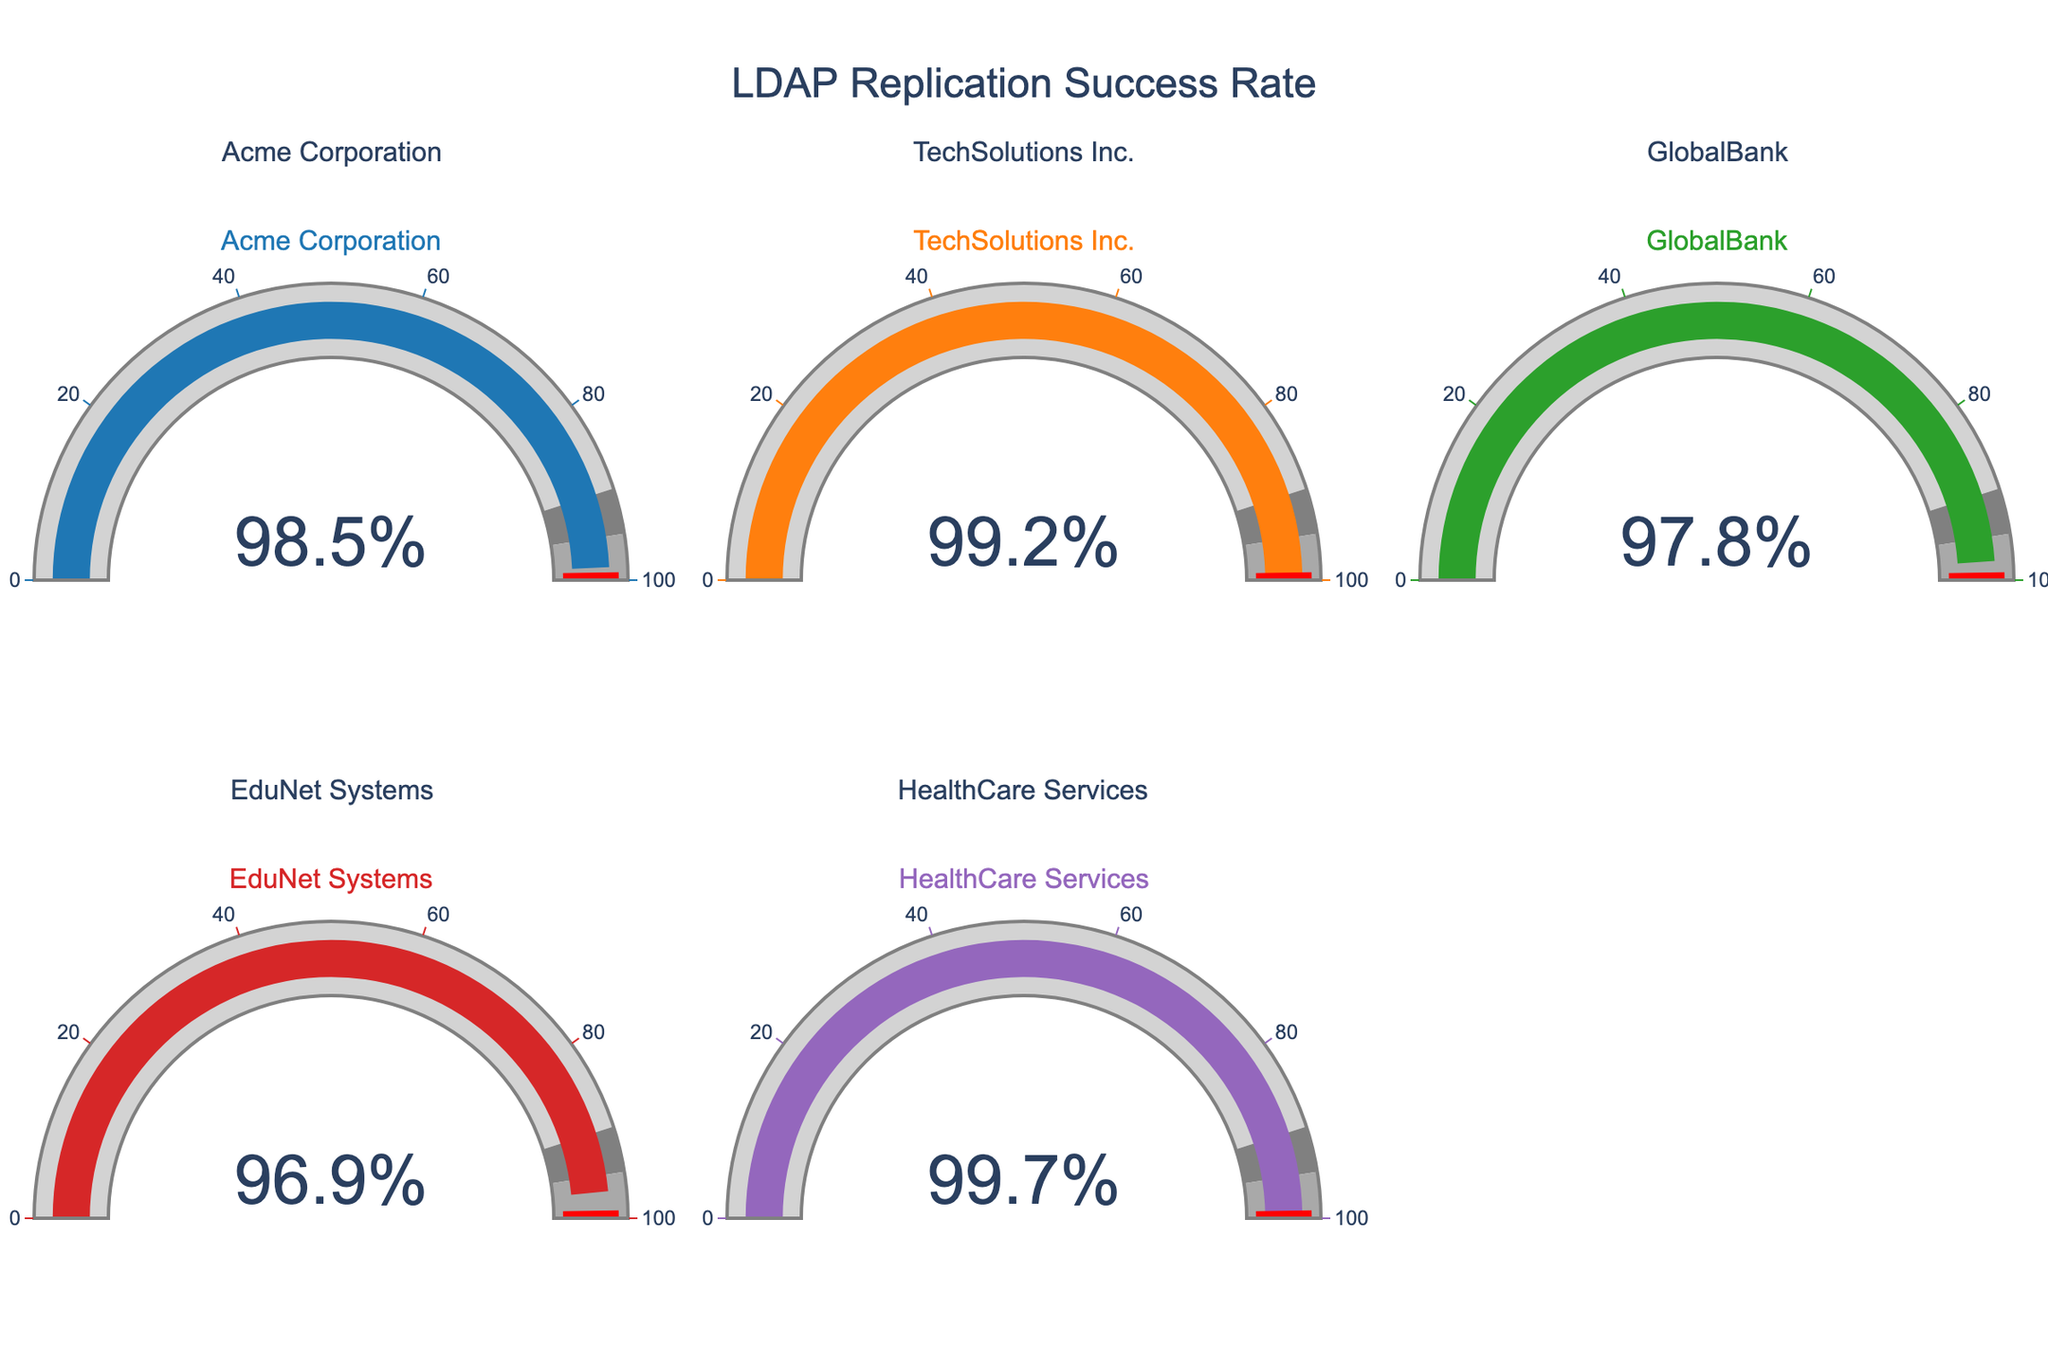What is the title of the figure? The title is usually positioned at the top of the figure and provides a brief description of what the figure is about. In this case, the title is "LDAP Replication Success Rate".
Answer: LDAP Replication Success Rate Which organization has the highest replication success rate? The Gauge Chart shows replication success rates for different organizations. By comparing the values displayed, the highest replication success rate is seen for HealthCare Services at 99.7%.
Answer: HealthCare Services What is the replication success rate for EduNet Systems? Each gauge in the figure explicitly shows the success rate for respective organizations. The success rate for EduNet Systems can be directly observed from its gauge.
Answer: 96.9% How much higher is TechSolutions Inc.'s replication success rate compared to GlobalBank? The replication success rate for TechSolutions Inc. is 99.2% and for GlobalBank it is 97.8%. Subtract the latter from the former to find the difference: 99.2 - 97.8 = 1.4%.
Answer: 1.4% Which two organizations have success rates above 99%? By looking at the gauges, the organizations with success rates above 99% are those that display values higher than 99%. These are HealthCare Services (99.7%) and TechSolutions Inc. (99.2%).
Answer: HealthCare Services and TechSolutions Inc What is the average replication success rate across all the organizations? Sum the replication success rates of all organizations and then divide by the number of organizations: (98.5 + 99.2 + 97.8 + 96.9 + 99.7) / 5 = 98.42%.
Answer: 98.42% Is any organization's replication success rate below 97%? By examining each gauge, we can see that only EduNet Systems has a success rate close to the 97% threshold, but its exact rate is 96.9%, which is below 97%.
Answer: Yes Which organization's replication success rate is closest to 97%? Among the listed organizations, GlobalBank has a success rate of 97.8% while EduNet Systems has 96.9%. The success rate closest to 97% is EduNet Systems'.
Answer: EduNet Systems What is the range of the replication success rates displayed in the figure? The highest value is 99.7% (HealthCare Services) and the lowest is 96.9% (EduNet Systems). Subtract the lowest from the highest to find the range: 99.7 - 96.9 = 2.8%.
Answer: 2.8% 